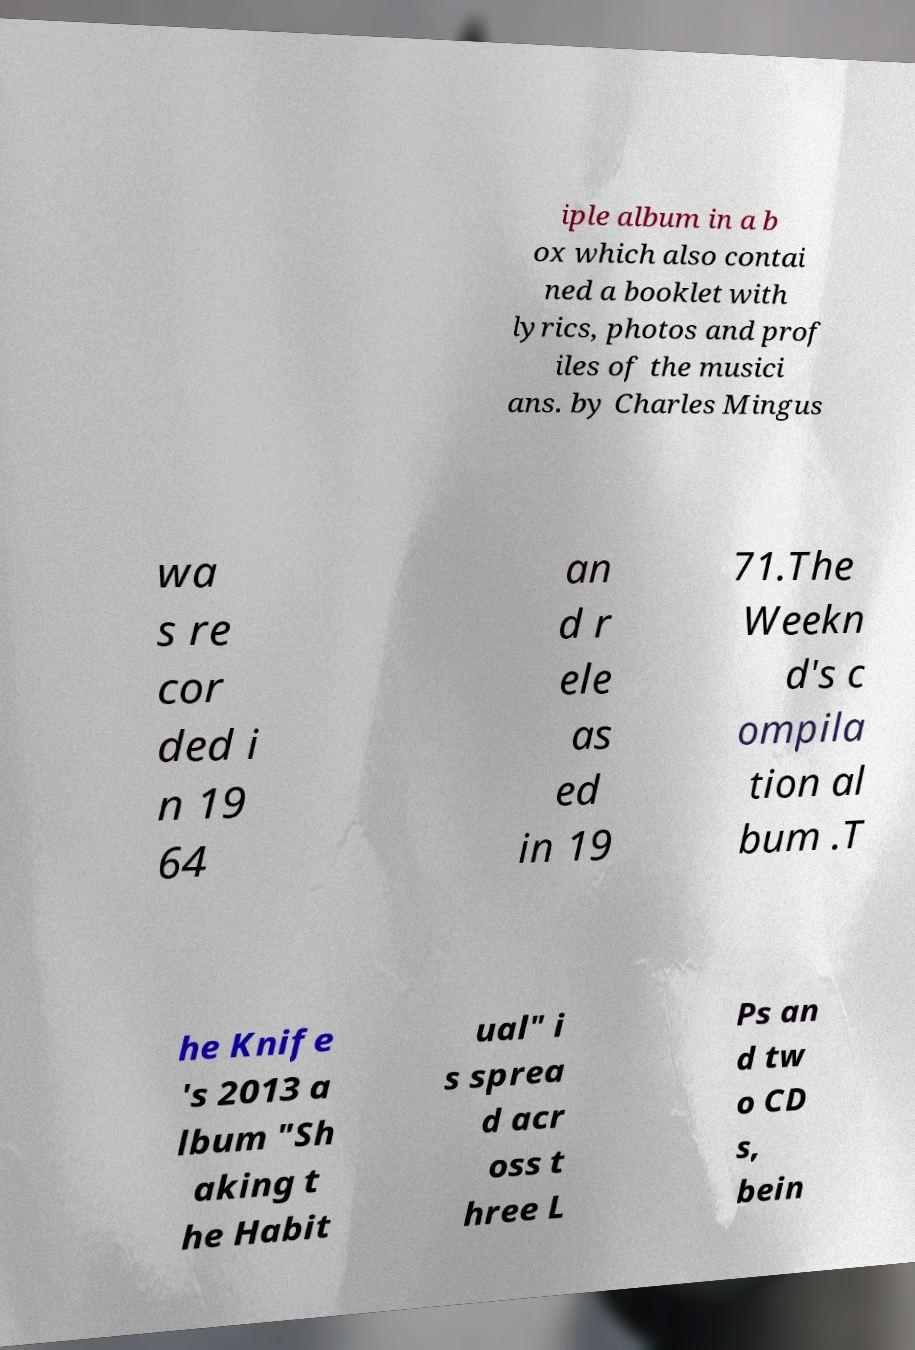What messages or text are displayed in this image? I need them in a readable, typed format. iple album in a b ox which also contai ned a booklet with lyrics, photos and prof iles of the musici ans. by Charles Mingus wa s re cor ded i n 19 64 an d r ele as ed in 19 71.The Weekn d's c ompila tion al bum .T he Knife 's 2013 a lbum "Sh aking t he Habit ual" i s sprea d acr oss t hree L Ps an d tw o CD s, bein 